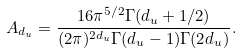Convert formula to latex. <formula><loc_0><loc_0><loc_500><loc_500>A _ { d _ { u } } = \frac { 1 6 \pi ^ { 5 / 2 } \Gamma ( d _ { u } + 1 / 2 ) } { ( 2 \pi ) ^ { 2 d _ { u } } \Gamma ( d _ { u } - 1 ) \Gamma ( 2 d _ { u } ) } .</formula> 